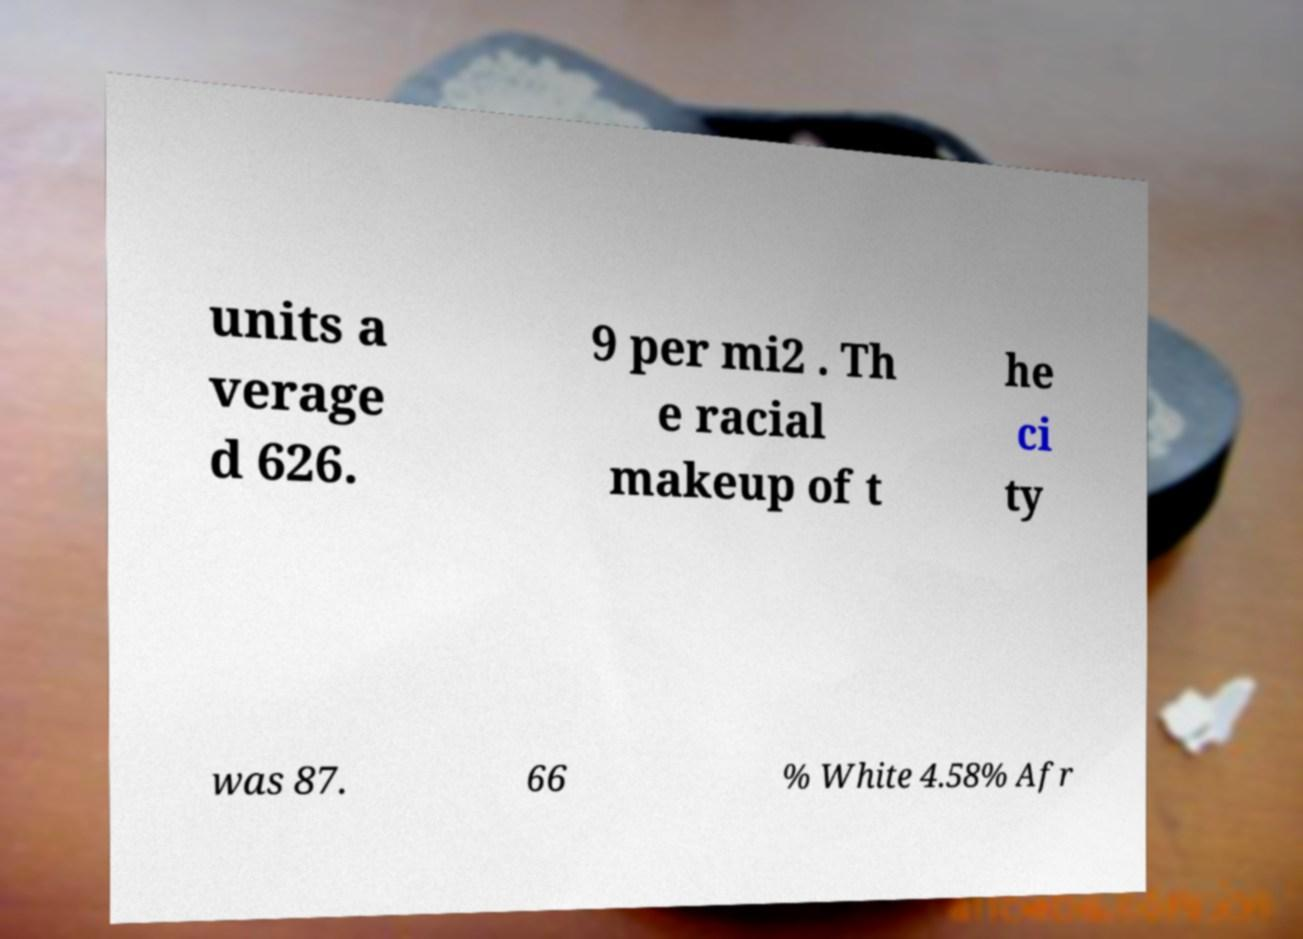For documentation purposes, I need the text within this image transcribed. Could you provide that? units a verage d 626. 9 per mi2 . Th e racial makeup of t he ci ty was 87. 66 % White 4.58% Afr 